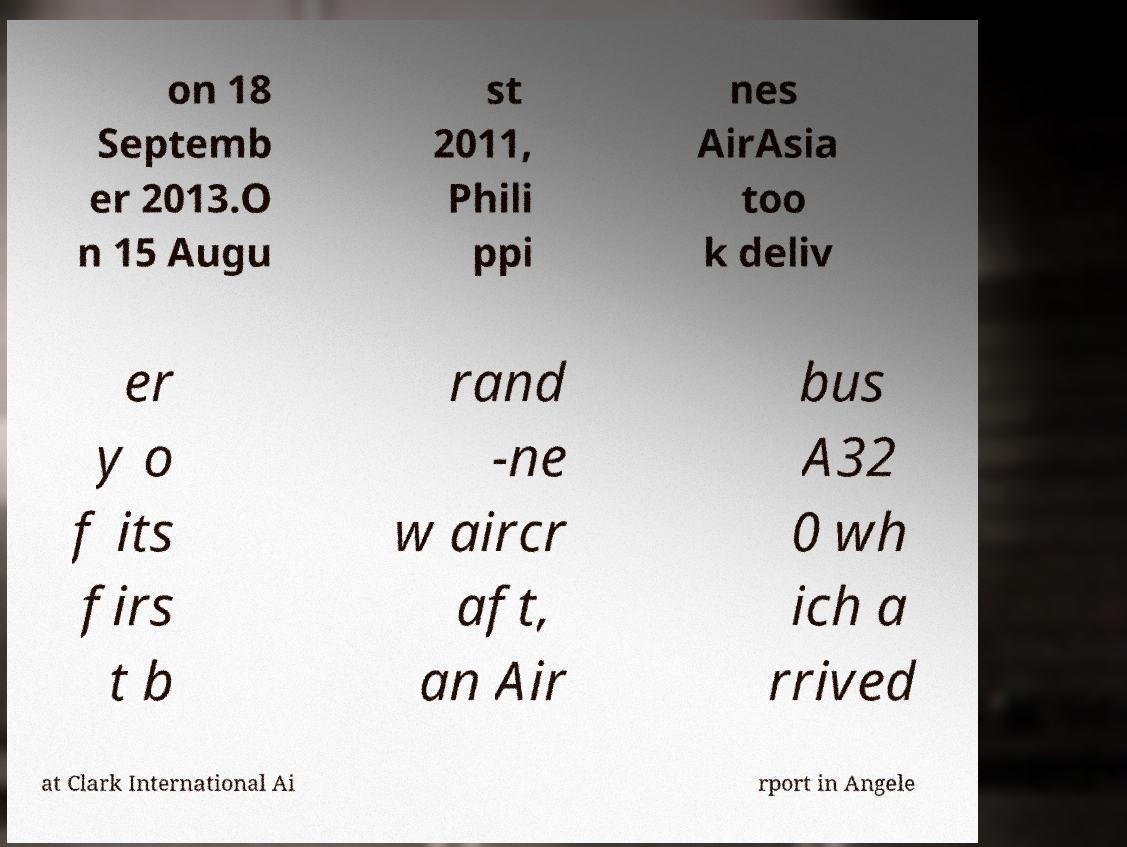Can you read and provide the text displayed in the image?This photo seems to have some interesting text. Can you extract and type it out for me? on 18 Septemb er 2013.O n 15 Augu st 2011, Phili ppi nes AirAsia too k deliv er y o f its firs t b rand -ne w aircr aft, an Air bus A32 0 wh ich a rrived at Clark International Ai rport in Angele 